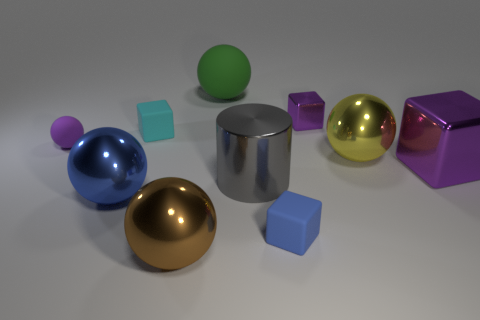Is there a tiny blue object that has the same material as the large blue sphere? Upon closer inspection, it seems that while there is a tiny blue cube in the image, it does not have the same glossy material finish as the large blue sphere. The sphere reflects light with a smooth and shiny appearance, indicating it has a different texture or finish compared to the cube, which has a matte surface. 